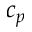Convert formula to latex. <formula><loc_0><loc_0><loc_500><loc_500>c _ { p }</formula> 